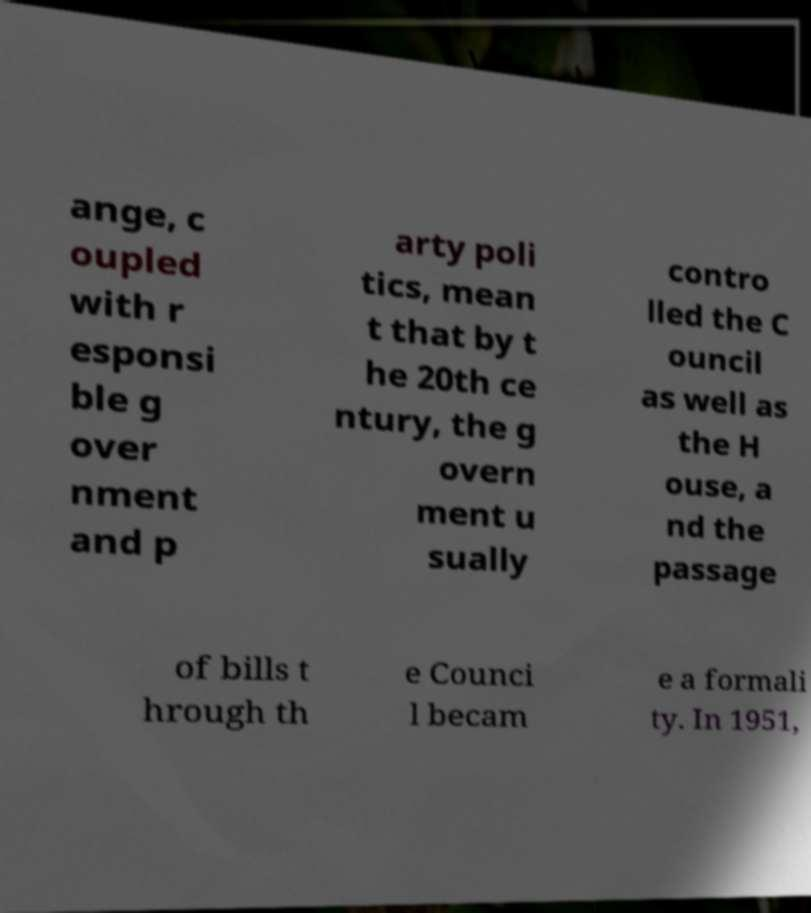Please identify and transcribe the text found in this image. ange, c oupled with r esponsi ble g over nment and p arty poli tics, mean t that by t he 20th ce ntury, the g overn ment u sually contro lled the C ouncil as well as the H ouse, a nd the passage of bills t hrough th e Counci l becam e a formali ty. In 1951, 